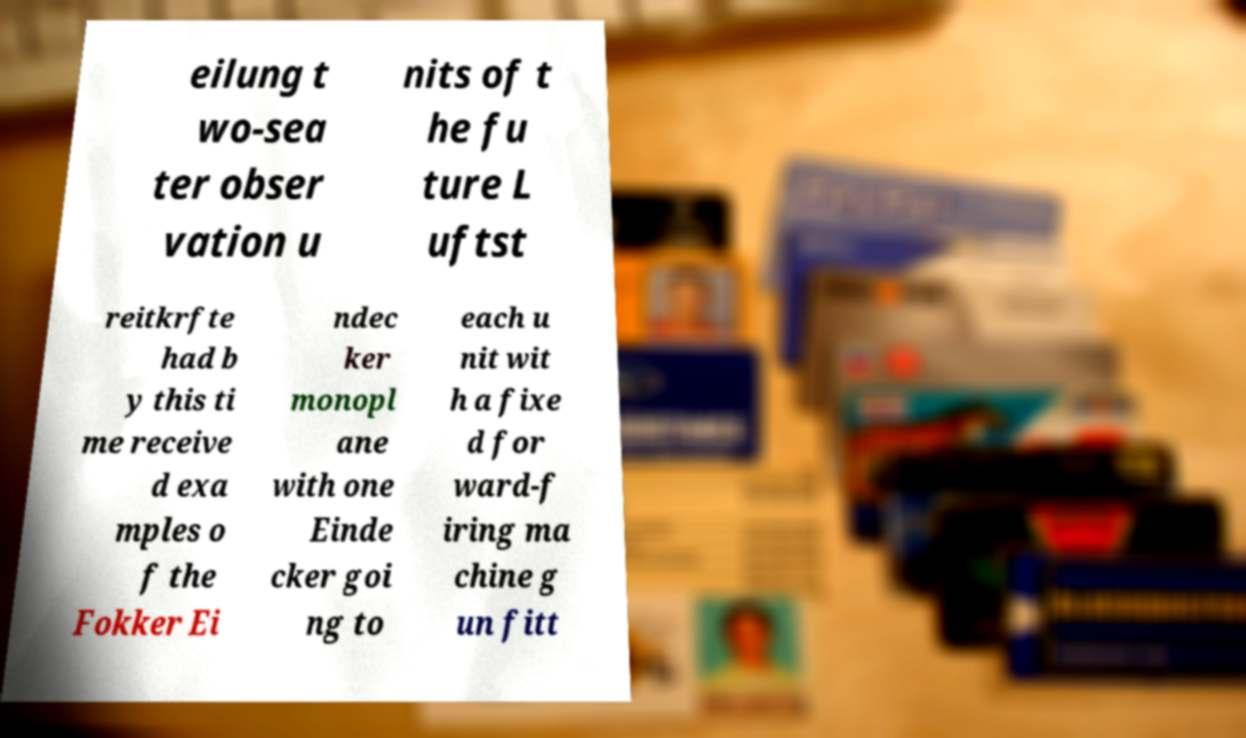For documentation purposes, I need the text within this image transcribed. Could you provide that? eilung t wo-sea ter obser vation u nits of t he fu ture L uftst reitkrfte had b y this ti me receive d exa mples o f the Fokker Ei ndec ker monopl ane with one Einde cker goi ng to each u nit wit h a fixe d for ward-f iring ma chine g un fitt 